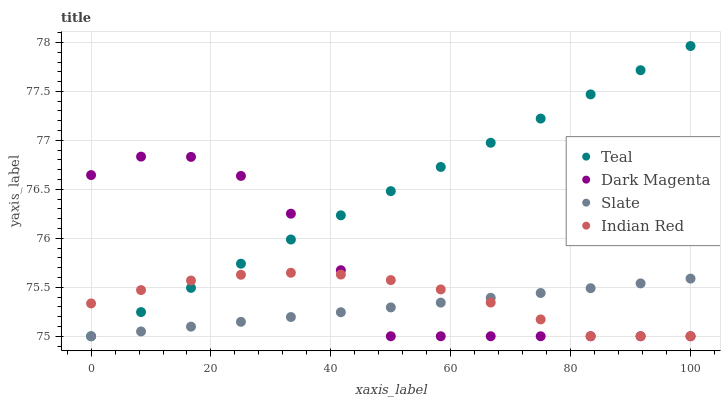Does Slate have the minimum area under the curve?
Answer yes or no. Yes. Does Teal have the maximum area under the curve?
Answer yes or no. Yes. Does Dark Magenta have the minimum area under the curve?
Answer yes or no. No. Does Dark Magenta have the maximum area under the curve?
Answer yes or no. No. Is Teal the smoothest?
Answer yes or no. Yes. Is Dark Magenta the roughest?
Answer yes or no. Yes. Is Slate the smoothest?
Answer yes or no. No. Is Slate the roughest?
Answer yes or no. No. Does Indian Red have the lowest value?
Answer yes or no. Yes. Does Teal have the highest value?
Answer yes or no. Yes. Does Dark Magenta have the highest value?
Answer yes or no. No. Does Indian Red intersect Dark Magenta?
Answer yes or no. Yes. Is Indian Red less than Dark Magenta?
Answer yes or no. No. Is Indian Red greater than Dark Magenta?
Answer yes or no. No. 